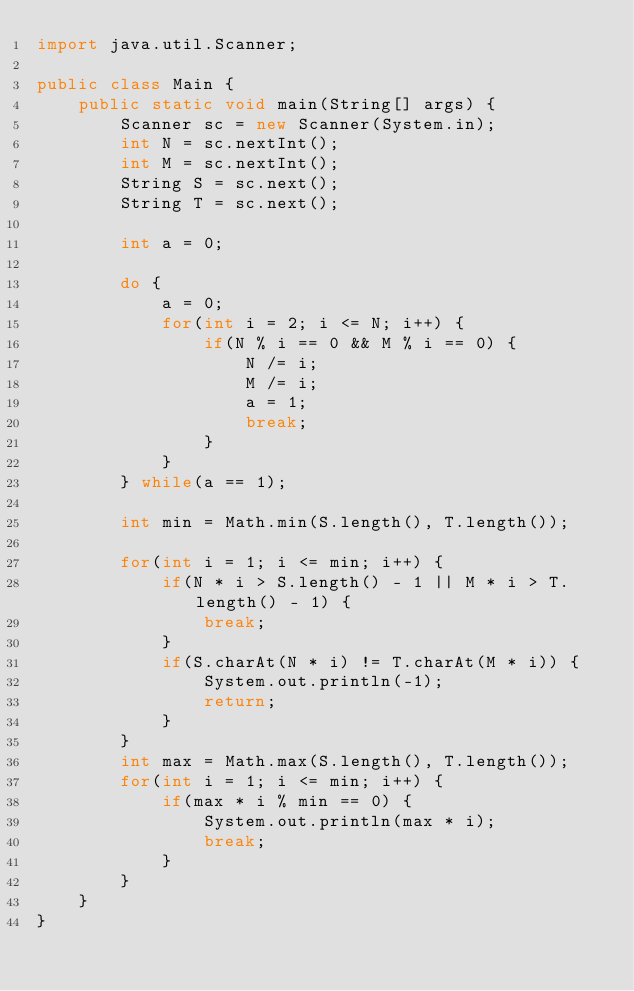Convert code to text. <code><loc_0><loc_0><loc_500><loc_500><_Java_>import java.util.Scanner;

public class Main {
	public static void main(String[] args) {
		Scanner sc = new Scanner(System.in);
		int N = sc.nextInt();
		int M = sc.nextInt();
		String S = sc.next();
		String T = sc.next();
		
		int a = 0;
		
		do {
			a = 0;
			for(int i = 2; i <= N; i++) {
				if(N % i == 0 && M % i == 0) {
					N /= i;
					M /= i;
					a = 1;
					break;
				}
			}
		} while(a == 1);
		
		int min = Math.min(S.length(), T.length());
		
		for(int i = 1; i <= min; i++) {
			if(N * i > S.length() - 1 || M * i > T.length() - 1) {
				break;
			}
			if(S.charAt(N * i) != T.charAt(M * i)) {
				System.out.println(-1);
				return;
			}
		}
		int max = Math.max(S.length(), T.length());
		for(int i = 1; i <= min; i++) {
			if(max * i % min == 0) {
				System.out.println(max * i);
				break;
			}
		}
	}
}
</code> 